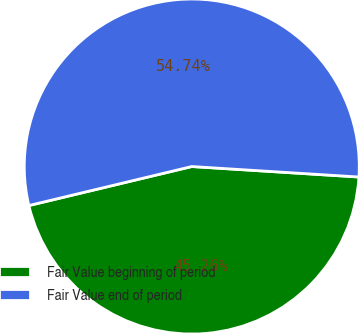Convert chart to OTSL. <chart><loc_0><loc_0><loc_500><loc_500><pie_chart><fcel>Fair Value beginning of period<fcel>Fair Value end of period<nl><fcel>45.26%<fcel>54.74%<nl></chart> 